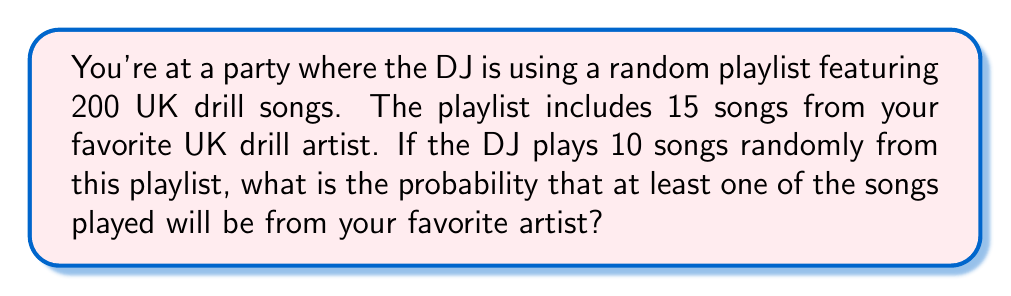Solve this math problem. Let's approach this step-by-step:

1) First, we need to calculate the probability of not hearing your favorite artist in a single song selection. This is:

   $P(\text{not favorite}) = \frac{200-15}{200} = \frac{185}{200} = 0.925$

2) Now, for 10 songs, we need to calculate the probability of not hearing your favorite artist in any of these 10 selections. Since each selection is independent, we multiply these probabilities:

   $P(\text{no favorite in 10 songs}) = (0.925)^{10} = 0.4631$

3) The probability of hearing at least one song from your favorite artist is the opposite of hearing no songs from them. In probability terms, this is the complement of the probability we just calculated:

   $P(\text{at least one favorite}) = 1 - P(\text{no favorite in 10 songs})$

   $= 1 - 0.4631 = 0.5369$

4) To express this as a percentage:

   $0.5369 \times 100\% = 53.69\%$

Therefore, the probability of hearing at least one song from your favorite UK drill artist is approximately 53.69%.
Answer: $53.69\%$ or $0.5369$ 